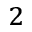Convert formula to latex. <formula><loc_0><loc_0><loc_500><loc_500>^ { 2 }</formula> 